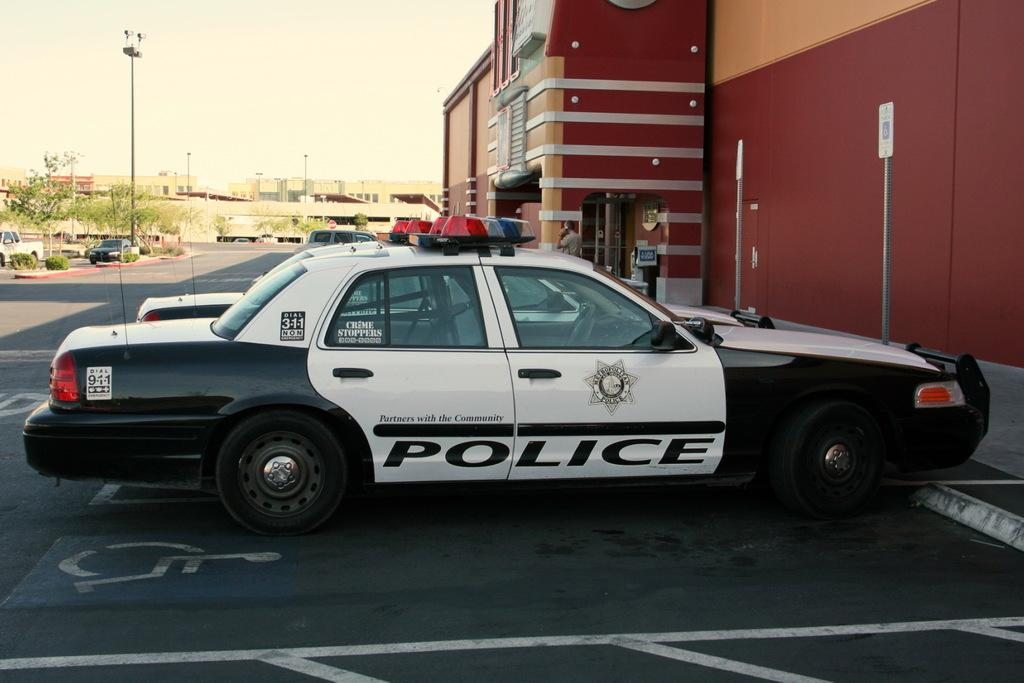What can be seen on the road in the image? There are vehicles on the road in the image. What type of natural elements are present in the image? There are trees and plants in the image. What type of man-made structures can be seen in the image? There are buildings in the image. What architectural features are visible in the image? There are windows, poles, and signboards in the image. What objects are present in the image? There are some objects in the image. Is there a person in the image? Yes, there is a person standing in the image. What can be seen in the background of the image? The sky is visible in the background of the image. What type of cheese is being gripped by the form in the image? There is no cheese or form present in the image. How does the person in the image maintain their grip on the form while holding the cheese? There is no person, form, or cheese present in the image. 